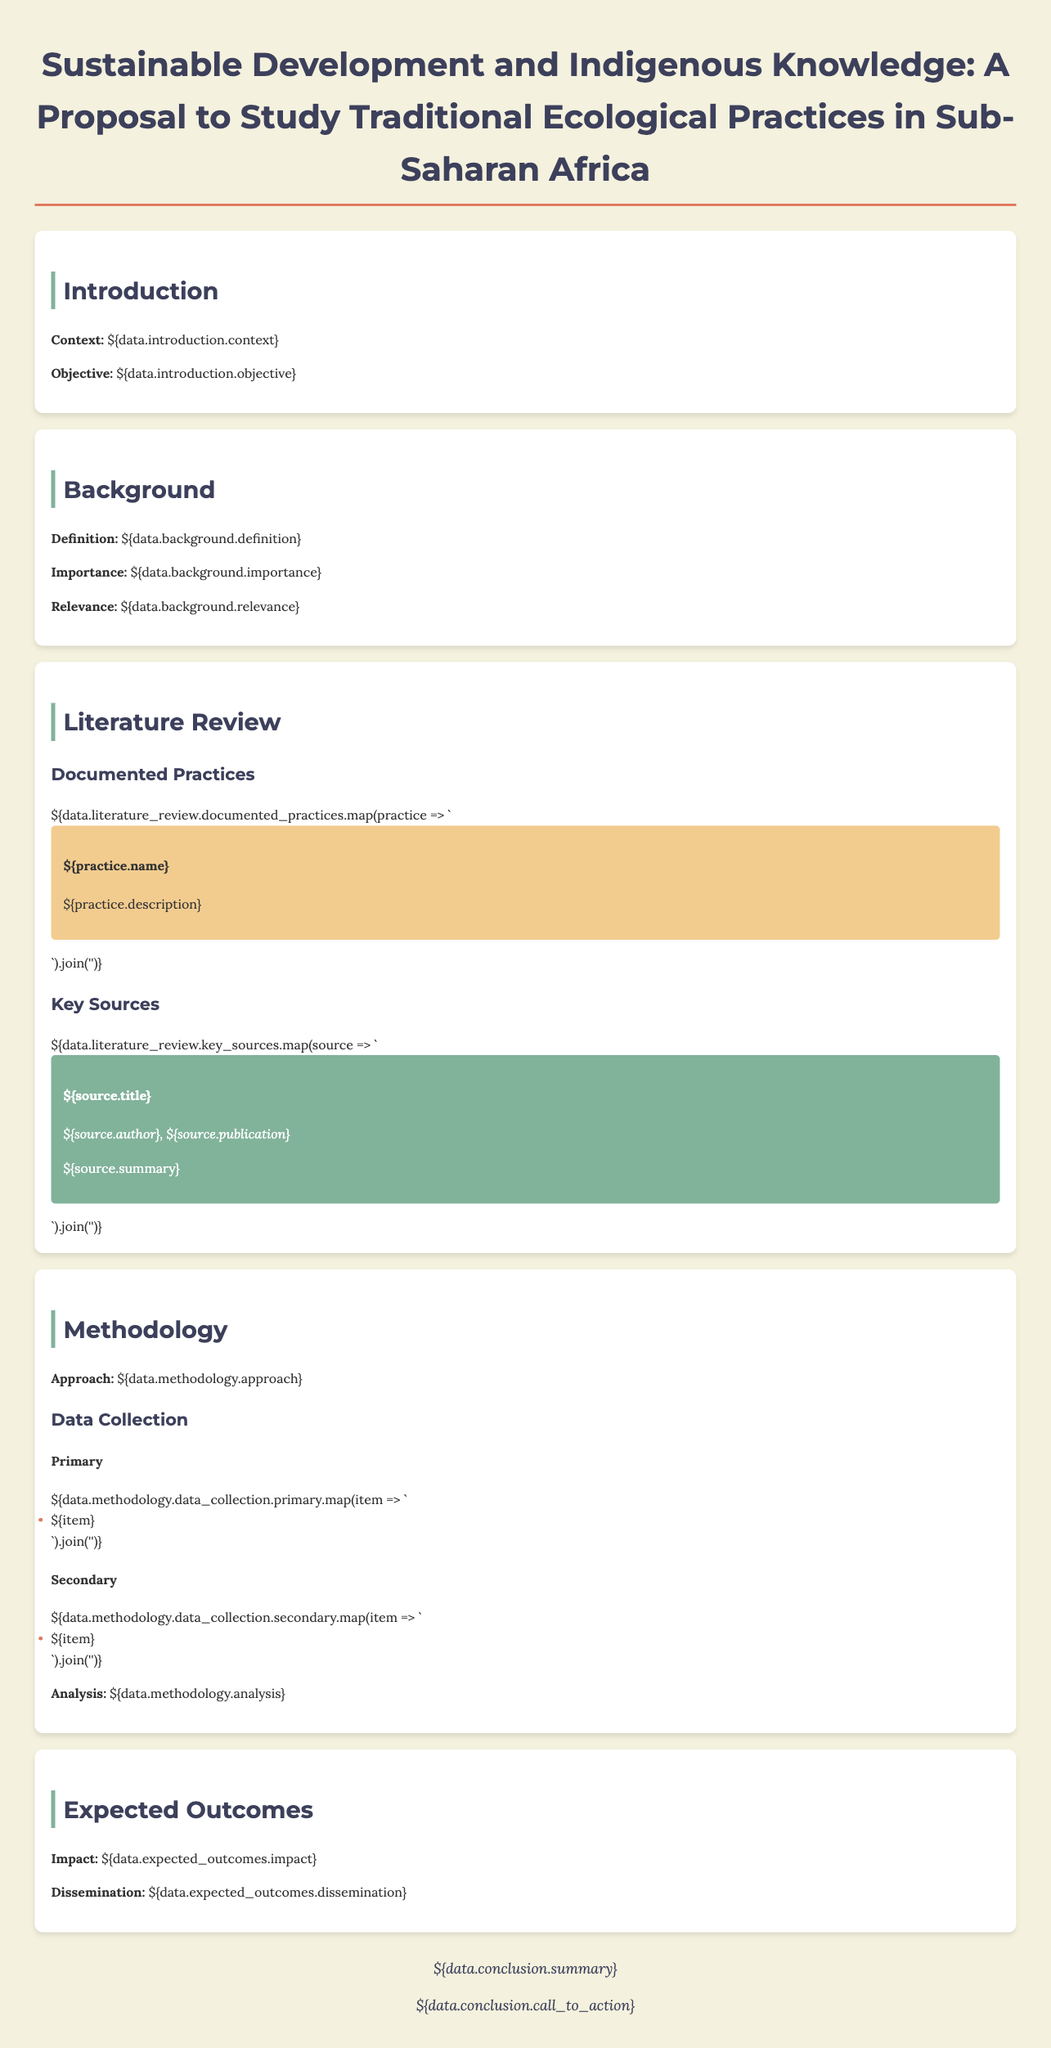what is the title of the proposal? The title provides the focus of the research, highlighting the relationship between sustainable development and indigenous knowledge.
Answer: Sustainable Development and Indigenous Knowledge: A Proposal to Study Traditional Ecological Practices in Sub-Saharan Africa what is the objective of the study? The objective summarizes the primary aim of the research as stated in the document.
Answer: ${data.introduction.objective} what is one example of a documented practice? The literature review section lists various traditional ecological practices, asking for a specific example.
Answer: ${data.literature_review.documented_practices[0].name} what is the approach mentioned in the methodology? The methodology section outlines the general strategy for conducting the research.
Answer: ${data.methodology.approach} how many data collection methods are listed under primary? This question requires counting the number of items listed under the primary data collection methods.
Answer: ${data.methodology.data_collection.primary.length} what is the expected impact of the study? This information pertains to what the researchers anticipate the study will achieve or influence.
Answer: ${data.expected_outcomes.impact} name one of the key sources referenced in the literature review. The document provides a list of significant works that support the research, asking for one specific title.
Answer: ${data.literature_review.key_sources[0].title} what is the conclusion's call to action? The conclusion summarizes the main message and the proposed next steps or recommendations based on the findings.
Answer: ${data.conclusion.call_to_action} 